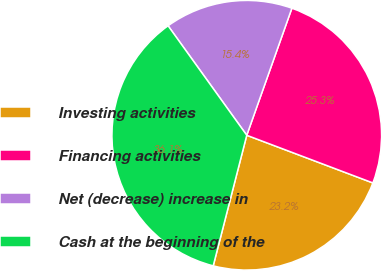<chart> <loc_0><loc_0><loc_500><loc_500><pie_chart><fcel>Investing activities<fcel>Financing activities<fcel>Net (decrease) increase in<fcel>Cash at the beginning of the<nl><fcel>23.25%<fcel>25.32%<fcel>15.35%<fcel>36.08%<nl></chart> 